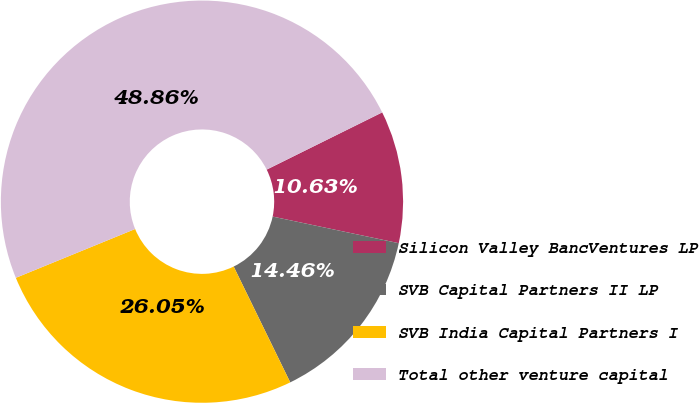<chart> <loc_0><loc_0><loc_500><loc_500><pie_chart><fcel>Silicon Valley BancVentures LP<fcel>SVB Capital Partners II LP<fcel>SVB India Capital Partners I<fcel>Total other venture capital<nl><fcel>10.63%<fcel>14.46%<fcel>26.05%<fcel>48.86%<nl></chart> 